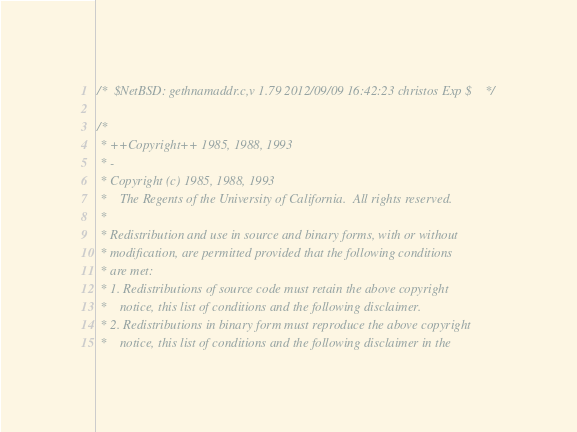Convert code to text. <code><loc_0><loc_0><loc_500><loc_500><_C_>/*	$NetBSD: gethnamaddr.c,v 1.79 2012/09/09 16:42:23 christos Exp $	*/

/*
 * ++Copyright++ 1985, 1988, 1993
 * -
 * Copyright (c) 1985, 1988, 1993
 *    The Regents of the University of California.  All rights reserved.
 * 
 * Redistribution and use in source and binary forms, with or without
 * modification, are permitted provided that the following conditions
 * are met:
 * 1. Redistributions of source code must retain the above copyright
 *    notice, this list of conditions and the following disclaimer.
 * 2. Redistributions in binary form must reproduce the above copyright
 *    notice, this list of conditions and the following disclaimer in the</code> 